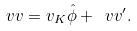<formula> <loc_0><loc_0><loc_500><loc_500>\ v v = v _ { K } \hat { \phi } + \ v v ^ { \prime } .</formula> 